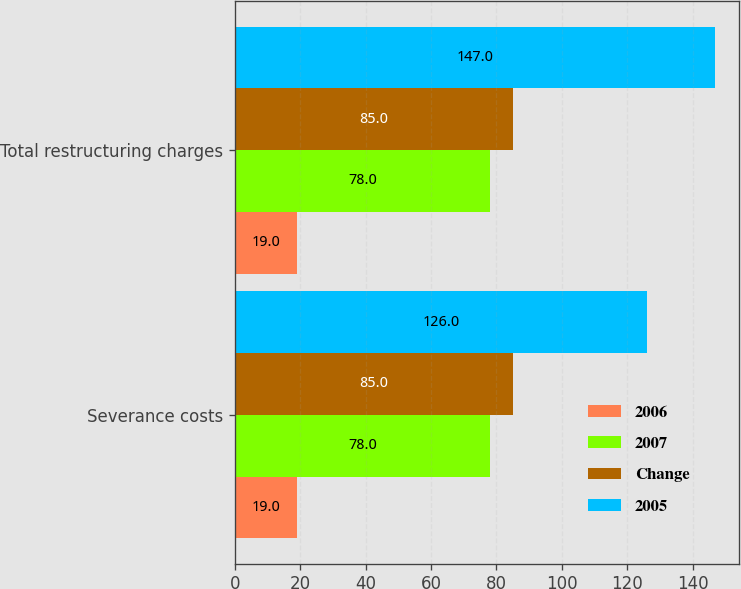Convert chart to OTSL. <chart><loc_0><loc_0><loc_500><loc_500><stacked_bar_chart><ecel><fcel>Severance costs<fcel>Total restructuring charges<nl><fcel>2006<fcel>19<fcel>19<nl><fcel>2007<fcel>78<fcel>78<nl><fcel>Change<fcel>85<fcel>85<nl><fcel>2005<fcel>126<fcel>147<nl></chart> 